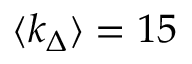<formula> <loc_0><loc_0><loc_500><loc_500>\langle k _ { \Delta } \rangle = 1 5</formula> 